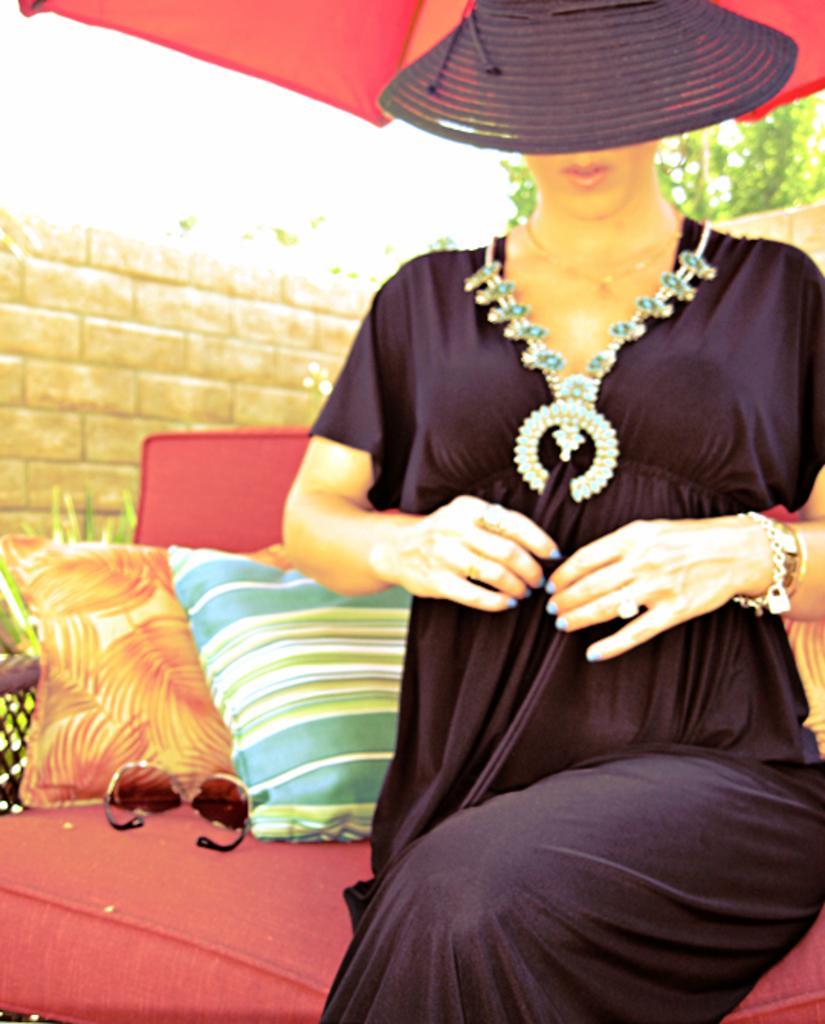Can you describe this image briefly? In this image we can see a lady sitting on the couch, and she is wearing a hat, there are cushions, and sunglasses on the couch, also we can see the wall, and a plant. 